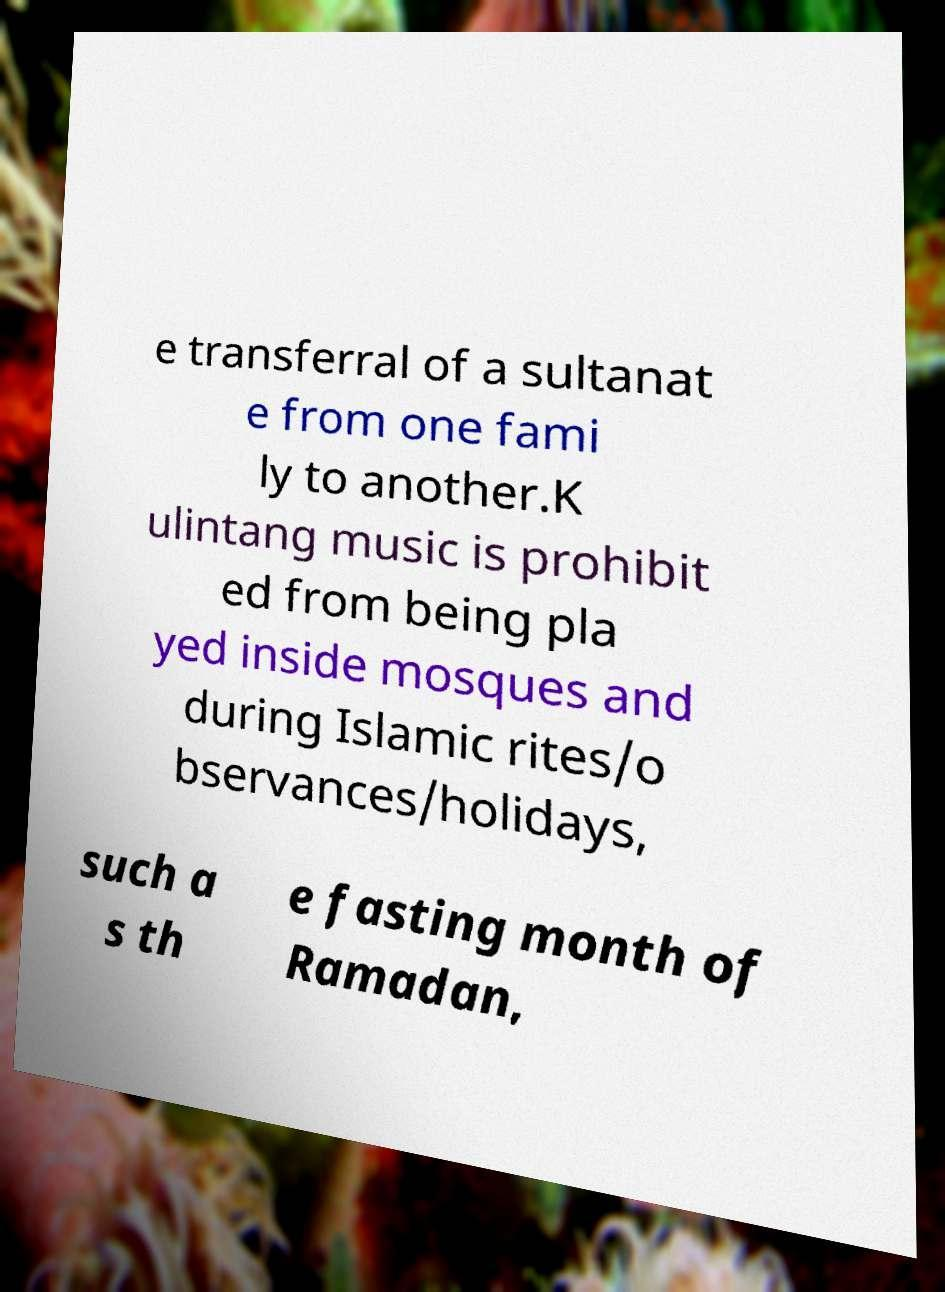Can you read and provide the text displayed in the image?This photo seems to have some interesting text. Can you extract and type it out for me? e transferral of a sultanat e from one fami ly to another.K ulintang music is prohibit ed from being pla yed inside mosques and during Islamic rites/o bservances/holidays, such a s th e fasting month of Ramadan, 